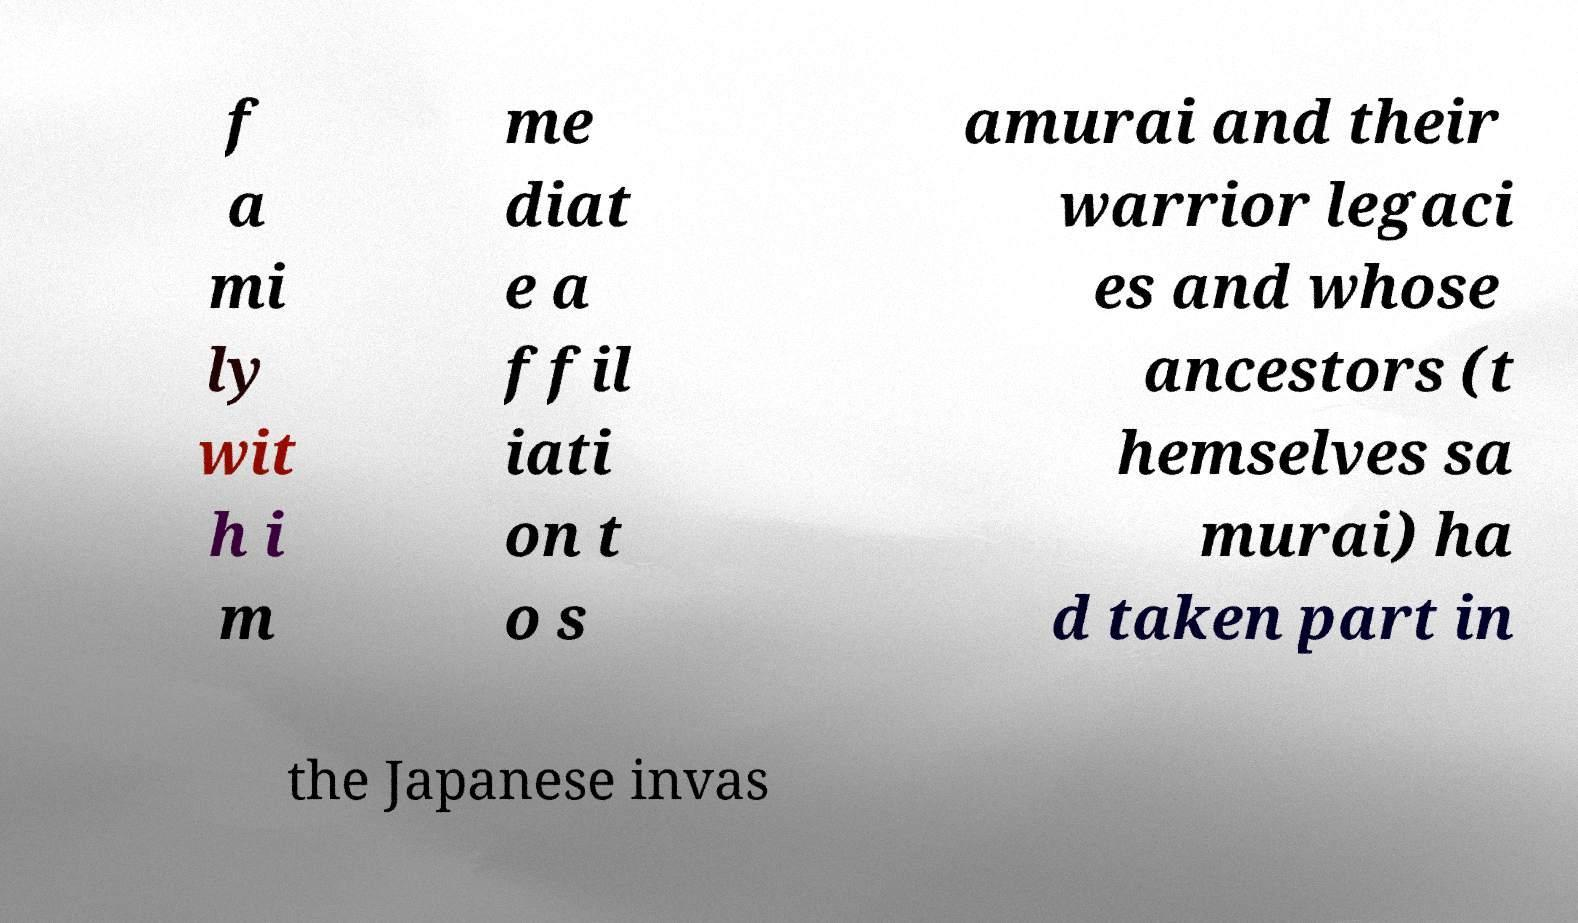There's text embedded in this image that I need extracted. Can you transcribe it verbatim? f a mi ly wit h i m me diat e a ffil iati on t o s amurai and their warrior legaci es and whose ancestors (t hemselves sa murai) ha d taken part in the Japanese invas 